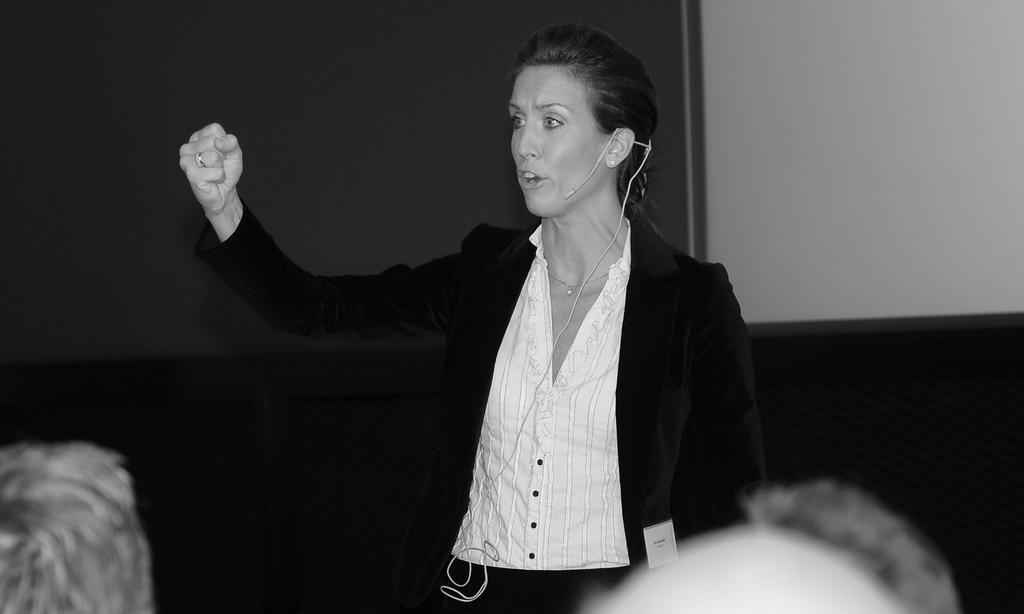In one or two sentences, can you explain what this image depicts? Black and white picture. This person wore a mic and speaking. 